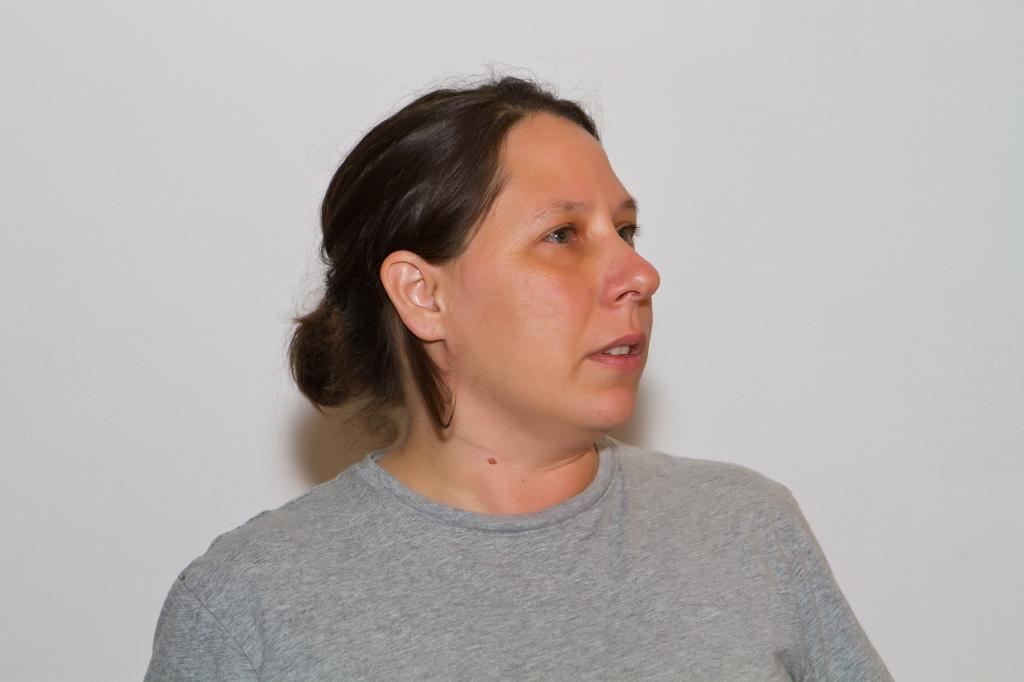Who is present in the image? There is a woman in the picture. What is the woman wearing in the image? The woman is wearing a t-shirt. What color is the t-shirt? The t-shirt is gray in color. What can be seen in the background of the image? There is a white color wall in the background of the image. What type of jewel can be seen on the woman's neck in the image? There is no jewel visible on the woman's neck in the image. How does the woman's breath appear in the image? The image does not show the woman's breath, so it cannot be determined from the image. 